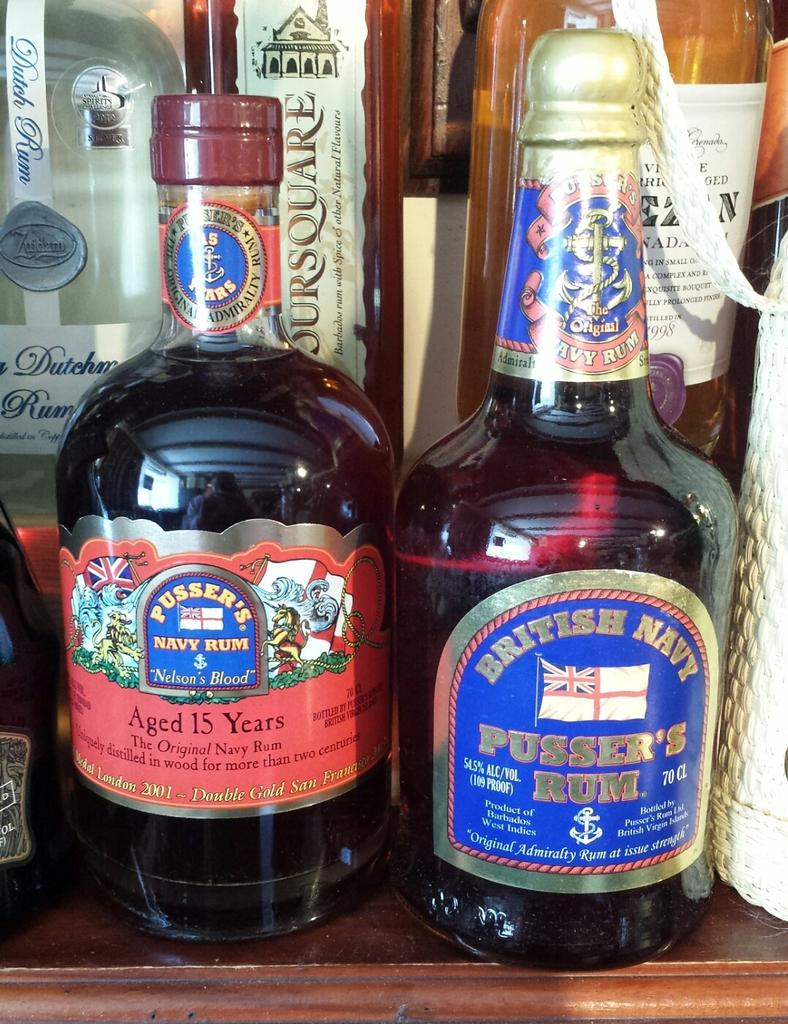<image>
Relay a brief, clear account of the picture shown. Two bottles of Pusser's rum, one of which is aged 15 years. 